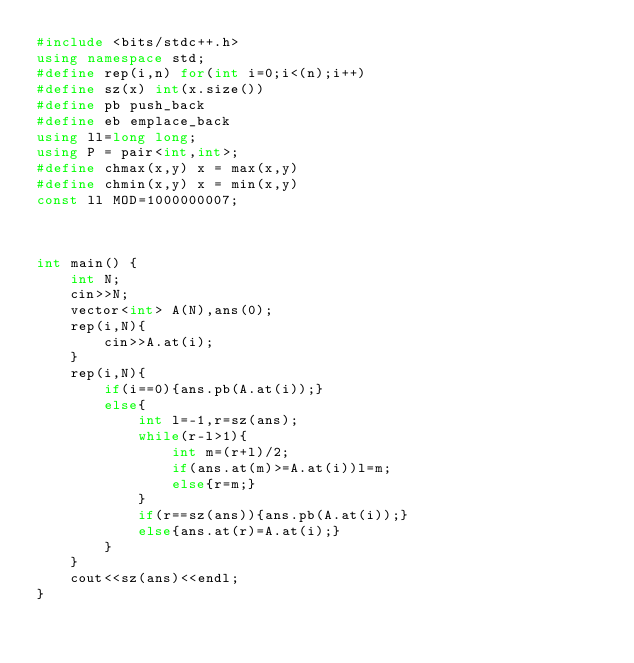<code> <loc_0><loc_0><loc_500><loc_500><_C++_>#include <bits/stdc++.h>
using namespace std;
#define rep(i,n) for(int i=0;i<(n);i++)
#define sz(x) int(x.size())
#define pb push_back
#define eb emplace_back
using ll=long long;
using P = pair<int,int>;
#define chmax(x,y) x = max(x,y)
#define chmin(x,y) x = min(x,y)
const ll MOD=1000000007;



int main() {
    int N;
    cin>>N;
    vector<int> A(N),ans(0);
    rep(i,N){
        cin>>A.at(i);
    }
    rep(i,N){
        if(i==0){ans.pb(A.at(i));}
        else{
            int l=-1,r=sz(ans);
            while(r-l>1){
                int m=(r+l)/2;
                if(ans.at(m)>=A.at(i))l=m;
                else{r=m;}
            }
            if(r==sz(ans)){ans.pb(A.at(i));}
            else{ans.at(r)=A.at(i);}
        }
    }
    cout<<sz(ans)<<endl;
}</code> 